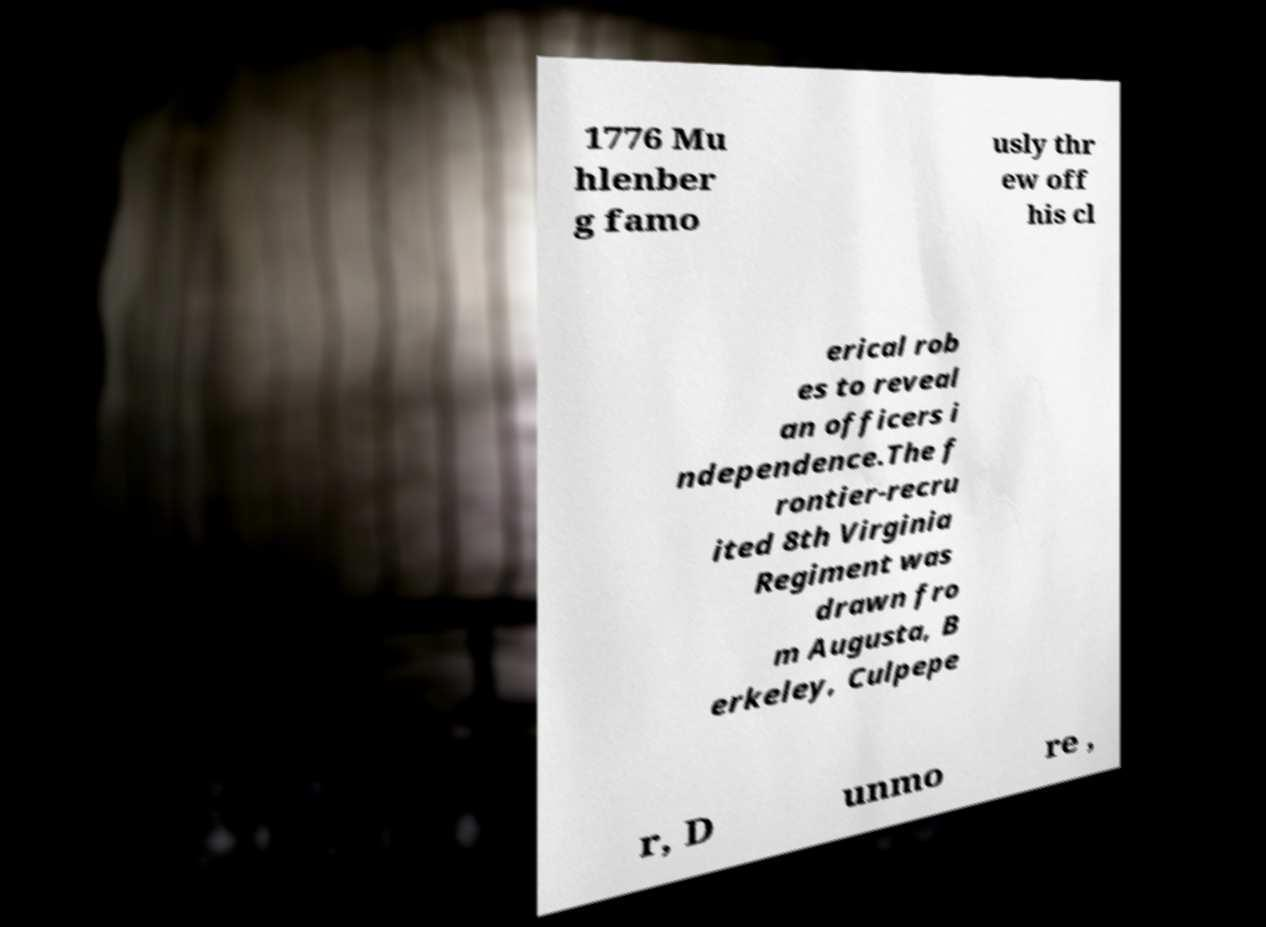Could you assist in decoding the text presented in this image and type it out clearly? 1776 Mu hlenber g famo usly thr ew off his cl erical rob es to reveal an officers i ndependence.The f rontier-recru ited 8th Virginia Regiment was drawn fro m Augusta, B erkeley, Culpepe r, D unmo re , 